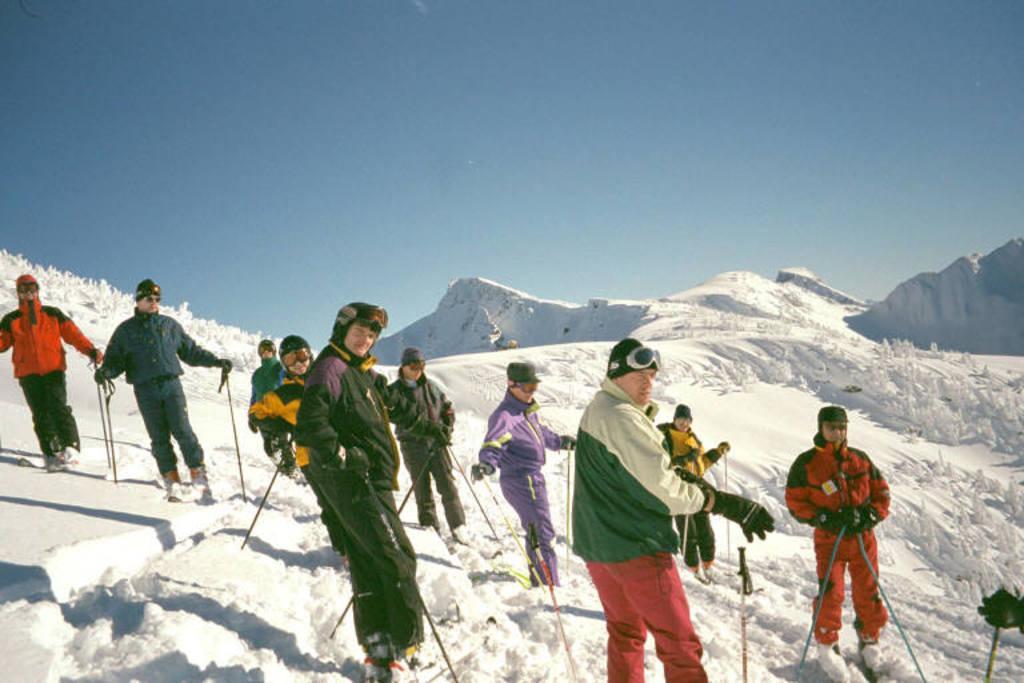Can you describe this image briefly? In this picture there are people standing and holding sticks and wire caps and goggles and we can see snow. In the background of the image we can see the sky. 